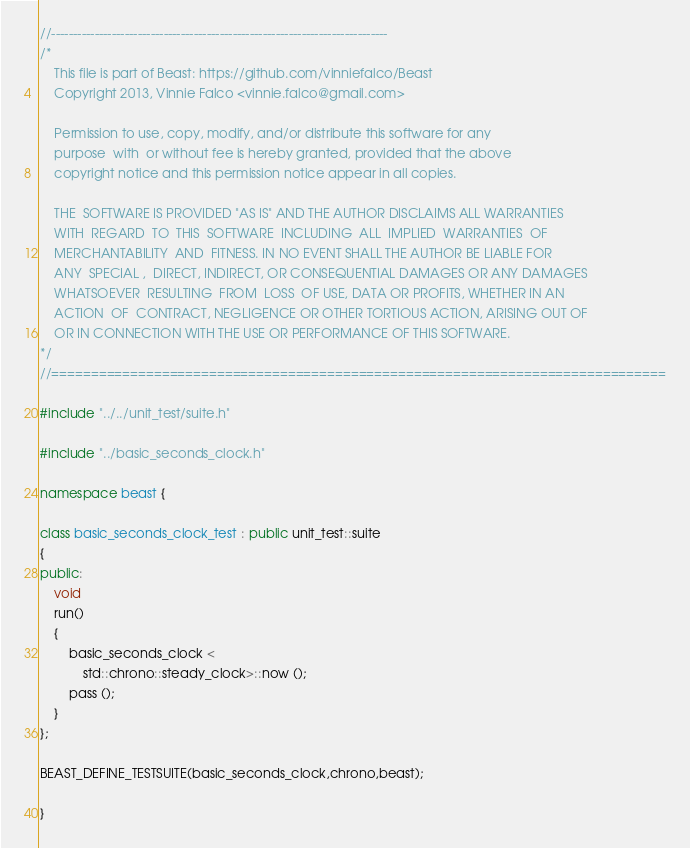<code> <loc_0><loc_0><loc_500><loc_500><_C++_>//------------------------------------------------------------------------------
/*
    This file is part of Beast: https://github.com/vinniefalco/Beast
    Copyright 2013, Vinnie Falco <vinnie.falco@gmail.com>

    Permission to use, copy, modify, and/or distribute this software for any
    purpose  with  or without fee is hereby granted, provided that the above
    copyright notice and this permission notice appear in all copies.

    THE  SOFTWARE IS PROVIDED "AS IS" AND THE AUTHOR DISCLAIMS ALL WARRANTIES
    WITH  REGARD  TO  THIS  SOFTWARE  INCLUDING  ALL  IMPLIED  WARRANTIES  OF
    MERCHANTABILITY  AND  FITNESS. IN NO EVENT SHALL THE AUTHOR BE LIABLE FOR
    ANY  SPECIAL ,  DIRECT, INDIRECT, OR CONSEQUENTIAL DAMAGES OR ANY DAMAGES
    WHATSOEVER  RESULTING  FROM  LOSS  OF USE, DATA OR PROFITS, WHETHER IN AN
    ACTION  OF  CONTRACT, NEGLIGENCE OR OTHER TORTIOUS ACTION, ARISING OUT OF
    OR IN CONNECTION WITH THE USE OR PERFORMANCE OF THIS SOFTWARE.
*/
//==============================================================================

#include "../../unit_test/suite.h"

#include "../basic_seconds_clock.h"

namespace beast {

class basic_seconds_clock_test : public unit_test::suite
{
public:
    void
    run()
    {
        basic_seconds_clock <
            std::chrono::steady_clock>::now ();
        pass ();
    }
};

BEAST_DEFINE_TESTSUITE(basic_seconds_clock,chrono,beast);

}
</code> 